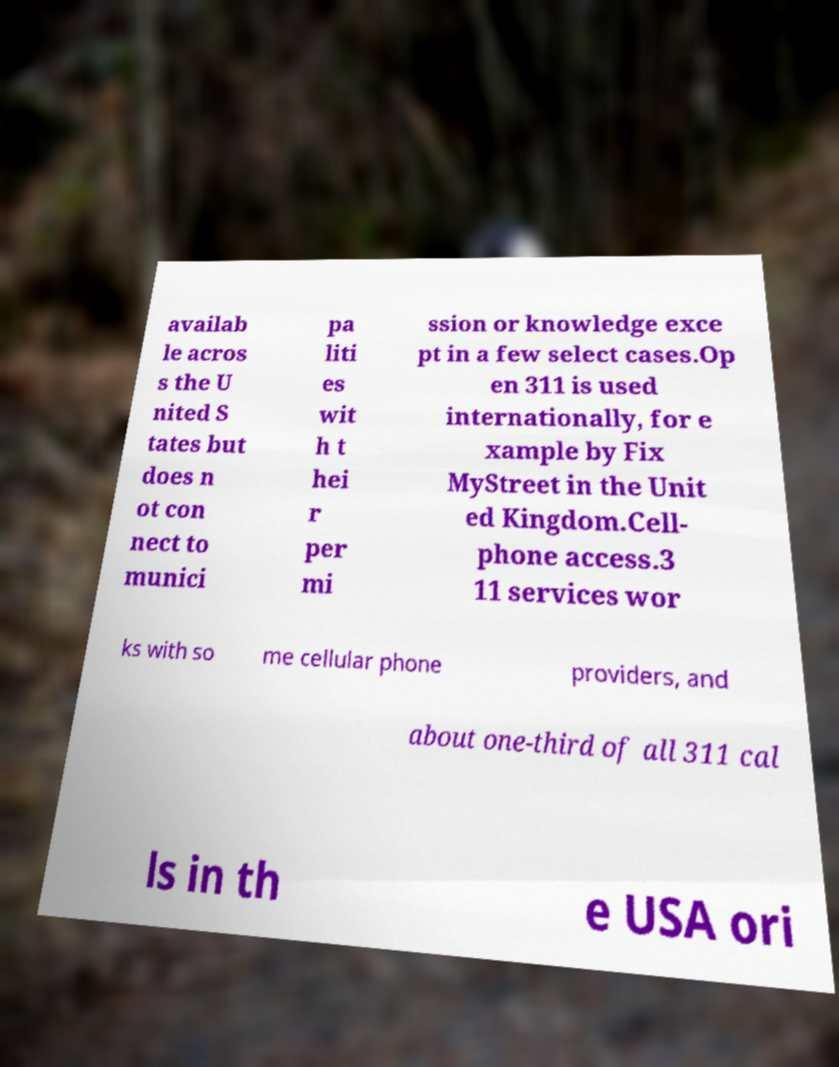What messages or text are displayed in this image? I need them in a readable, typed format. availab le acros s the U nited S tates but does n ot con nect to munici pa liti es wit h t hei r per mi ssion or knowledge exce pt in a few select cases.Op en 311 is used internationally, for e xample by Fix MyStreet in the Unit ed Kingdom.Cell- phone access.3 11 services wor ks with so me cellular phone providers, and about one-third of all 311 cal ls in th e USA ori 